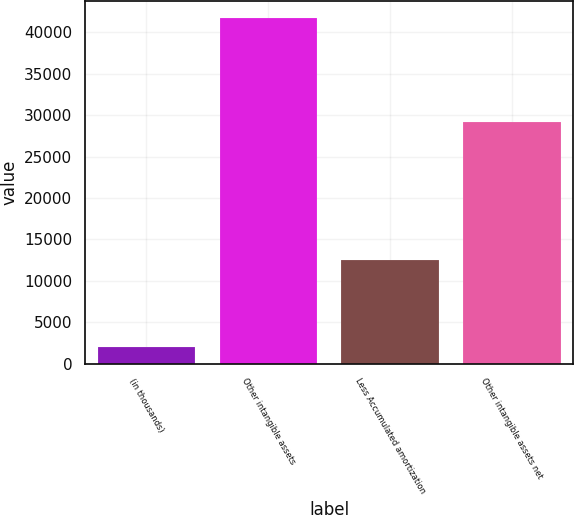Convert chart. <chart><loc_0><loc_0><loc_500><loc_500><bar_chart><fcel>(in thousands)<fcel>Other intangible assets<fcel>Less Accumulated amortization<fcel>Other intangible assets net<nl><fcel>2011<fcel>41702<fcel>12524<fcel>29178<nl></chart> 